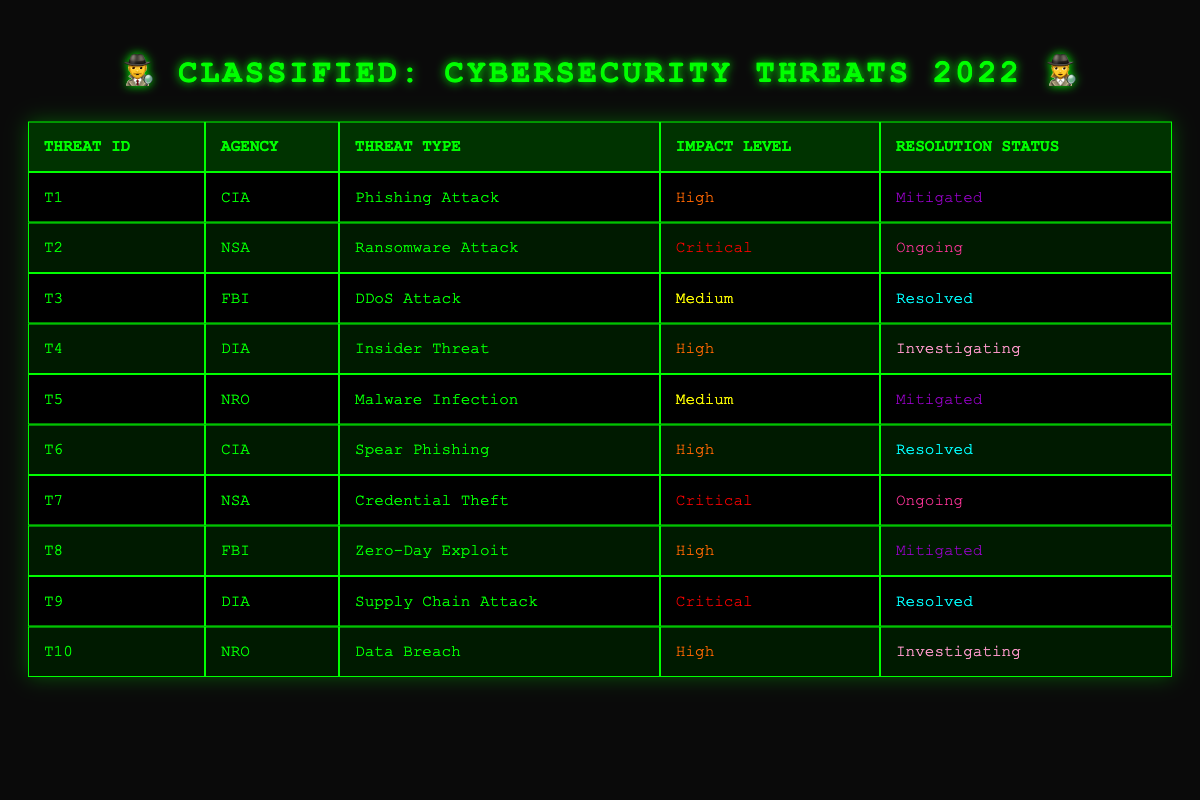What is the impact level of the threat from the CIA labeled as T1? The table shows that threat T1 is from the CIA, and it is categorized with an impact level labeled as "High".
Answer: High How many threats have a resolution status of "Ongoing"? By examining the resolution status column, threats T2 and T7 both have a status of "Ongoing". This totals to 2 threats.
Answer: 2 Is the resolution status of the NRO's threat T10 "Resolved"? The table lists the NRO's threat T10 with a resolution status of "Investigating", which indicates that it is not "Resolved".
Answer: No Which agency has faced the maximum number of threats categorized as "Critical" in 2022? The NSA has two threats (T2 and T7) categorized as "Critical", and the DIA also has one (T9). Therefore, the agency with the maximum number is the NSA with 2 threats.
Answer: NSA What is the total number of high impact threats that have been mitigated? There are threats T1, T6, and T8 from the CIA and FBI that are classified as "High" and have a resolution status of "Mitigated". Thus, the total is 3 high impact threats that have been mitigated.
Answer: 3 How many different threat types are listed for the FBI? The FBI has two distinct threat types listed in the table: "DDoS Attack" (T3) and "Zero-Day Exploit" (T8). Therefore, the FBI has 2 different threat types.
Answer: 2 Are there more resolved threats than investigating threats in the table? By counting, there are three resolved threats (T3, T6, and T9) compared to three investigating threats (T4 and T10), indicating they are equal in number.
Answer: No Which threat has both the highest impact level and has been resolved? The table shows that threat T9 categorized as "Supply Chain Attack" has the impact level "Critical" but has a status of “Resolved”, which indicates it has both high significance and the resolution has been attained.
Answer: T9 How many threats categorized as "High" are currently being investigated? The table indicates that both threats T4 and T10 have an "Investigating" status but only T4 is categorized as "High", therefore there is only one such threat.
Answer: 1 